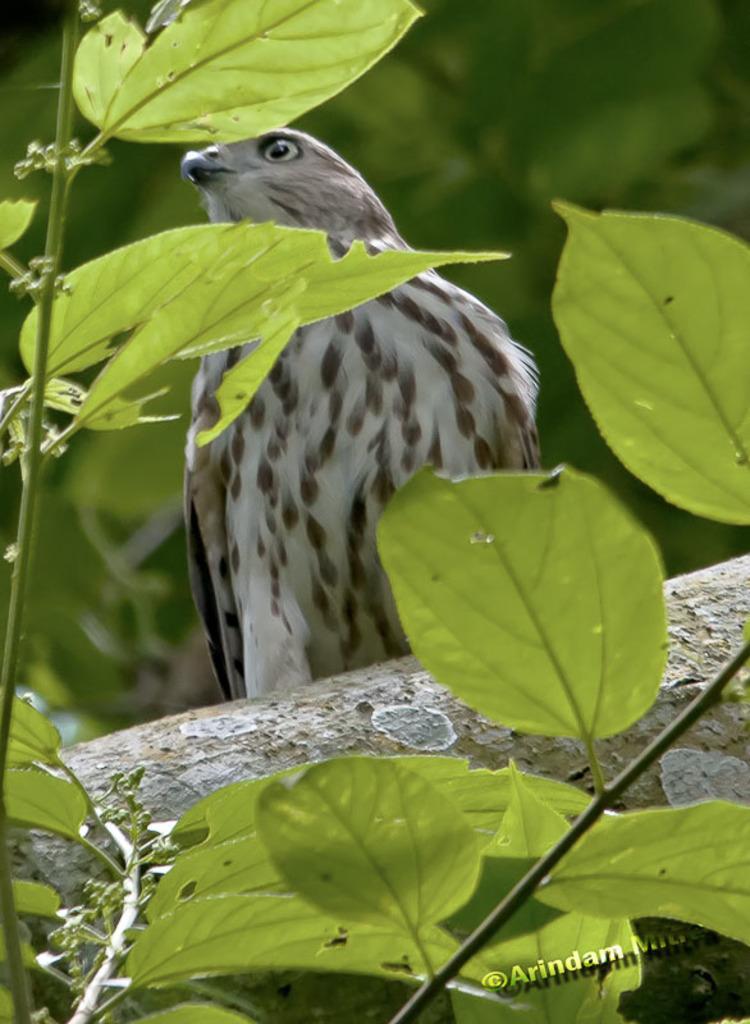Could you give a brief overview of what you see in this image? In this image there is a tree on that tree there is an eagle, in the background it is blurred, in the bottom right there is text. 